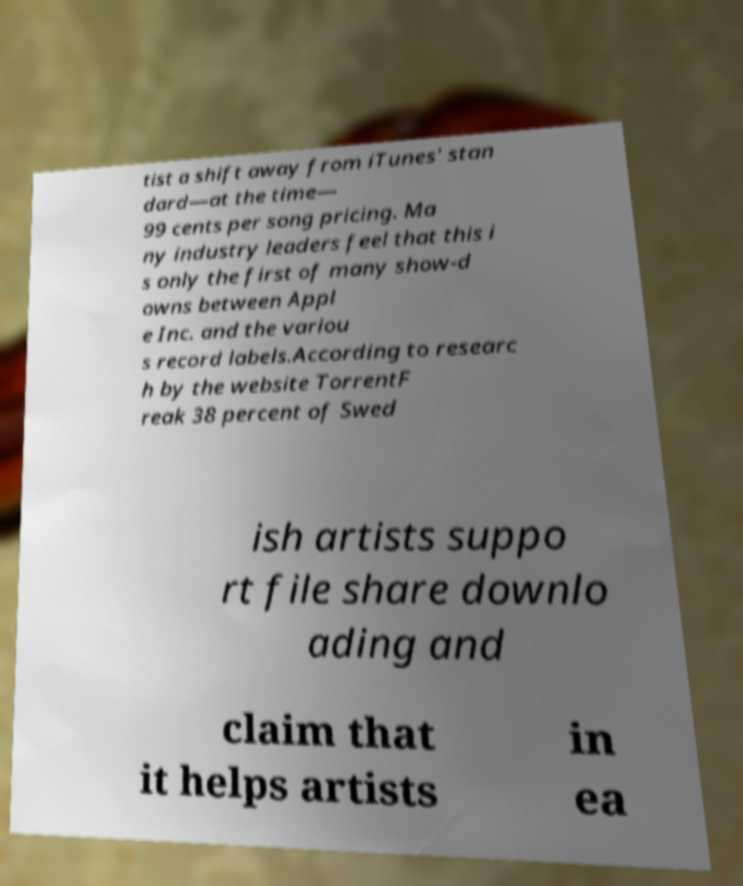Could you extract and type out the text from this image? tist a shift away from iTunes' stan dard—at the time— 99 cents per song pricing. Ma ny industry leaders feel that this i s only the first of many show-d owns between Appl e Inc. and the variou s record labels.According to researc h by the website TorrentF reak 38 percent of Swed ish artists suppo rt file share downlo ading and claim that it helps artists in ea 